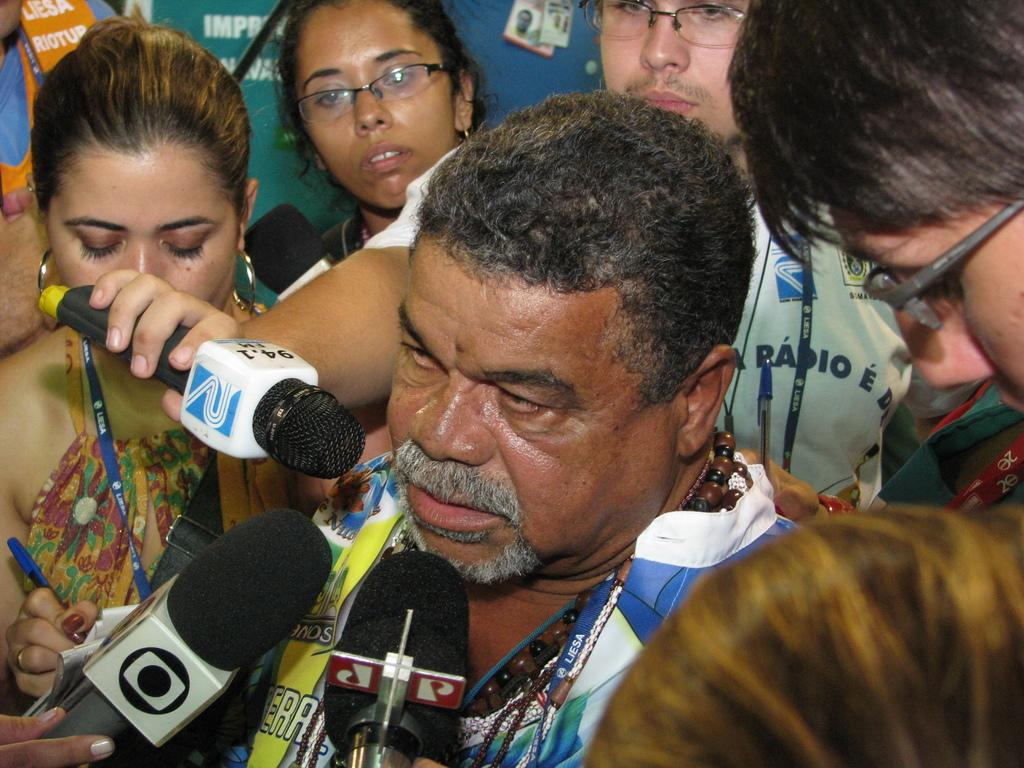How many people are in the image? There is a group of people in the image. What are some people doing in the image? Some people are holding objects. Can you describe the person in the middle of the image? The person in the middle is wearing beads chains. What type of juice is the queen drinking in the image? There is no queen or juice present in the image. Is there a pail visible in the image? There is no pail present in the image. 